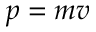<formula> <loc_0><loc_0><loc_500><loc_500>p = m v</formula> 